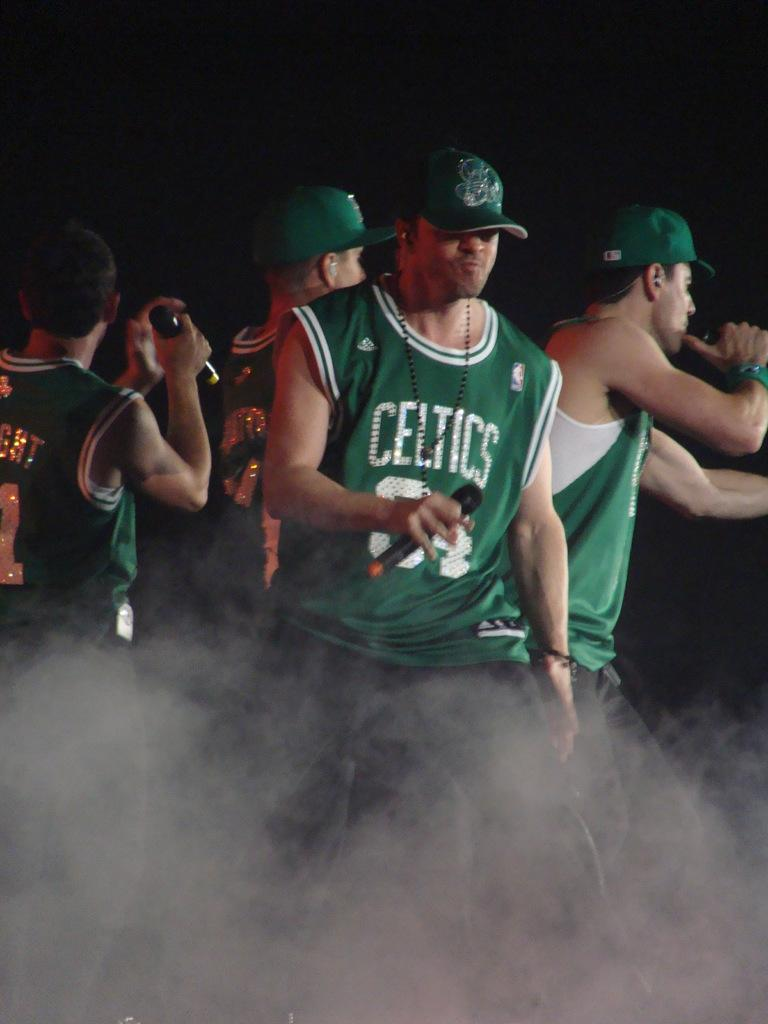<image>
Share a concise interpretation of the image provided. Men with microphones wearing green hats and green jerseys with the name Celtics on them. 